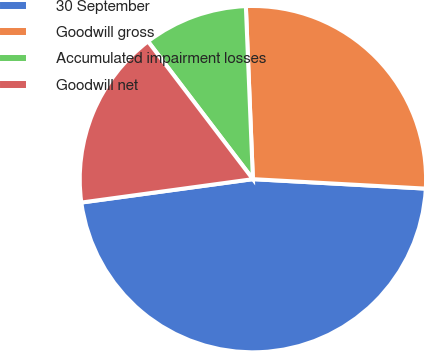<chart> <loc_0><loc_0><loc_500><loc_500><pie_chart><fcel>30 September<fcel>Goodwill gross<fcel>Accumulated impairment losses<fcel>Goodwill net<nl><fcel>46.97%<fcel>26.52%<fcel>9.71%<fcel>16.8%<nl></chart> 